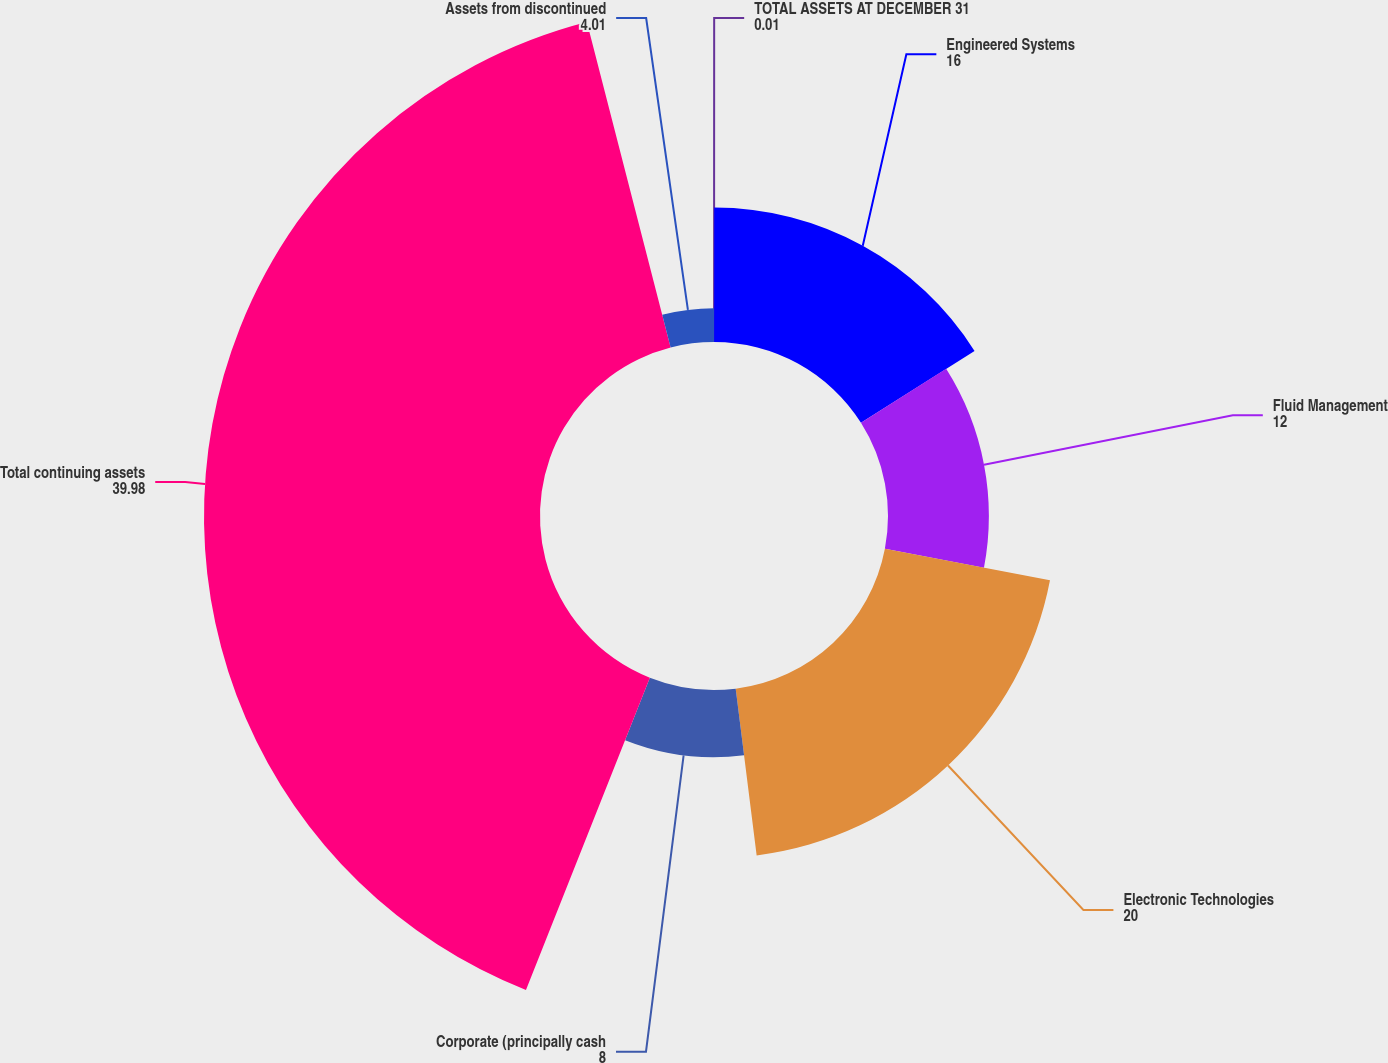Convert chart. <chart><loc_0><loc_0><loc_500><loc_500><pie_chart><fcel>TOTAL ASSETS AT DECEMBER 31<fcel>Engineered Systems<fcel>Fluid Management<fcel>Electronic Technologies<fcel>Corporate (principally cash<fcel>Total continuing assets<fcel>Assets from discontinued<nl><fcel>0.01%<fcel>16.0%<fcel>12.0%<fcel>20.0%<fcel>8.0%<fcel>39.98%<fcel>4.01%<nl></chart> 